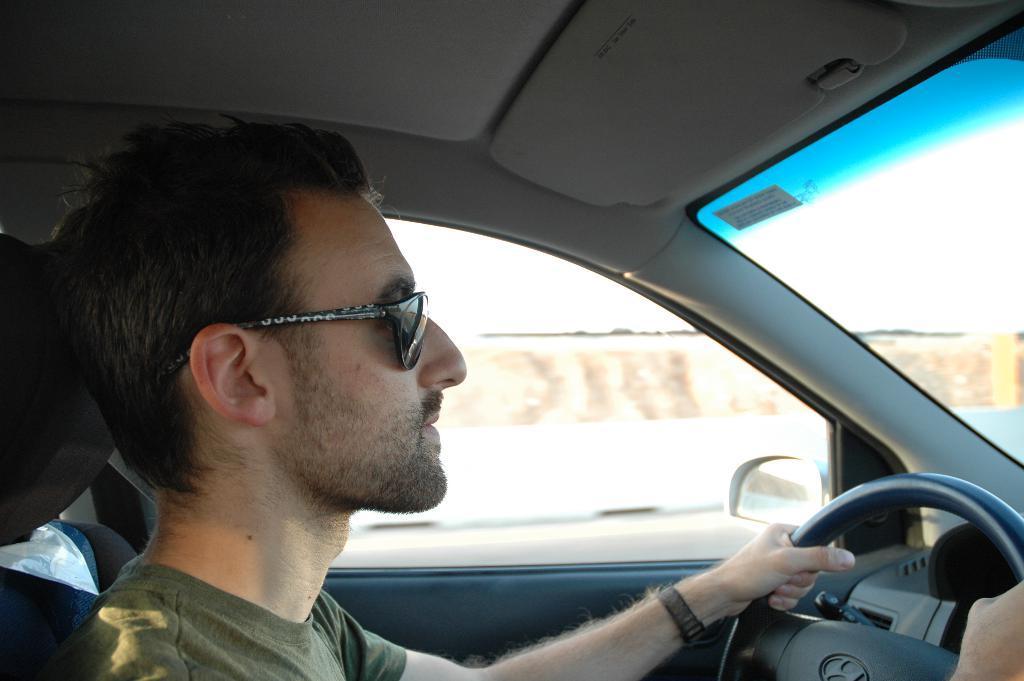Describe this image in one or two sentences. This is the picture of a person who is wearing the shades and holding the steering sitting in the car. 